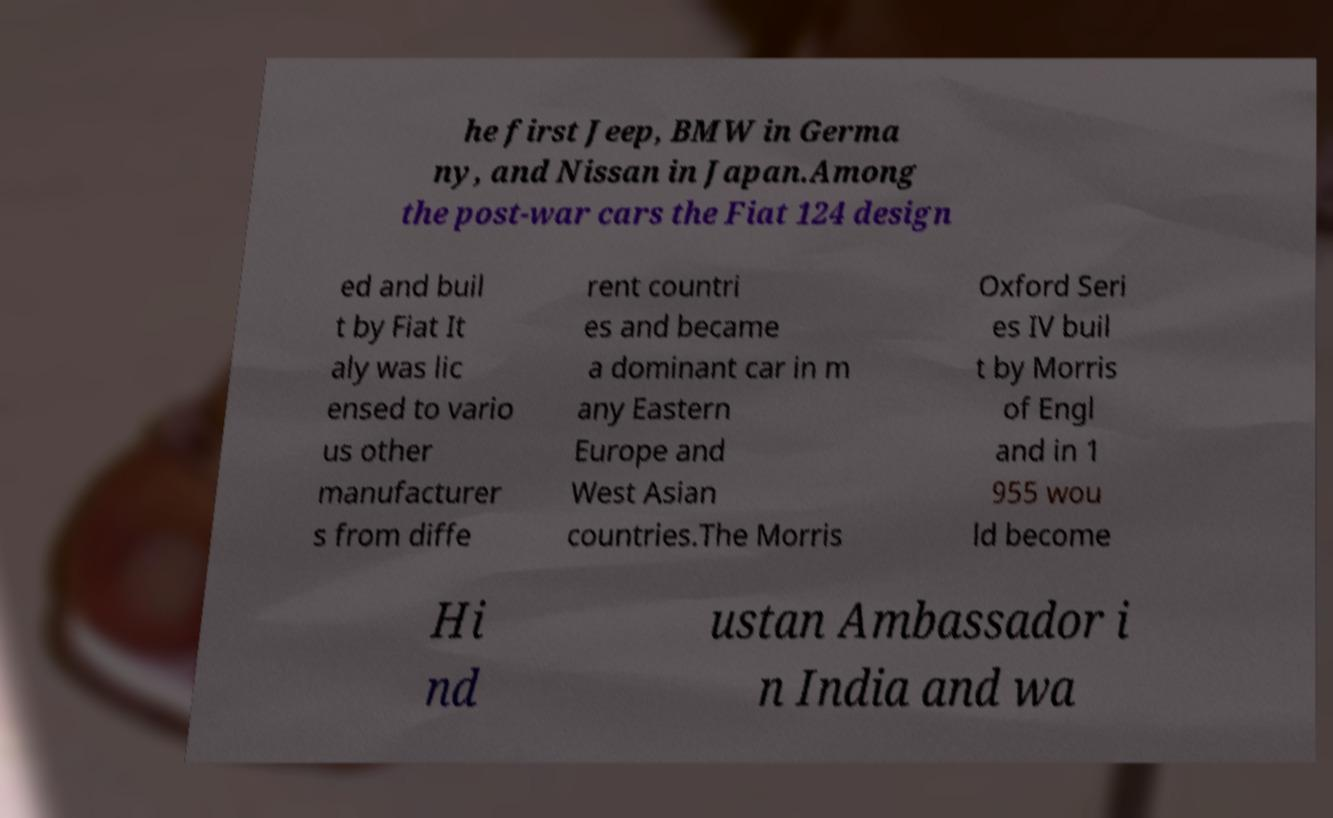Could you assist in decoding the text presented in this image and type it out clearly? he first Jeep, BMW in Germa ny, and Nissan in Japan.Among the post-war cars the Fiat 124 design ed and buil t by Fiat It aly was lic ensed to vario us other manufacturer s from diffe rent countri es and became a dominant car in m any Eastern Europe and West Asian countries.The Morris Oxford Seri es IV buil t by Morris of Engl and in 1 955 wou ld become Hi nd ustan Ambassador i n India and wa 